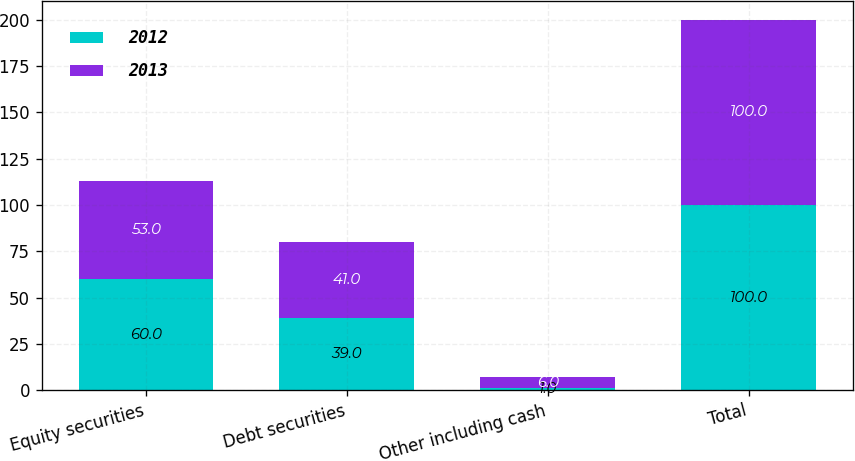Convert chart to OTSL. <chart><loc_0><loc_0><loc_500><loc_500><stacked_bar_chart><ecel><fcel>Equity securities<fcel>Debt securities<fcel>Other including cash<fcel>Total<nl><fcel>2012<fcel>60<fcel>39<fcel>1<fcel>100<nl><fcel>2013<fcel>53<fcel>41<fcel>6<fcel>100<nl></chart> 